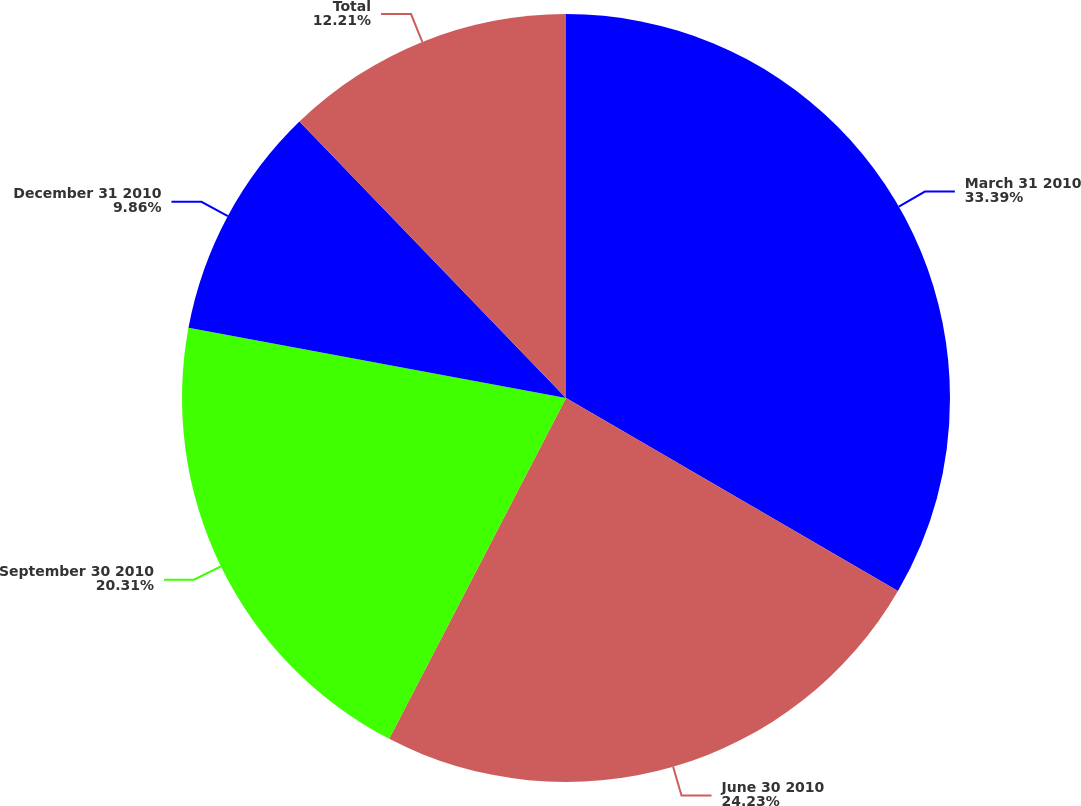<chart> <loc_0><loc_0><loc_500><loc_500><pie_chart><fcel>March 31 2010<fcel>June 30 2010<fcel>September 30 2010<fcel>December 31 2010<fcel>Total<nl><fcel>33.38%<fcel>24.23%<fcel>20.31%<fcel>9.86%<fcel>12.21%<nl></chart> 